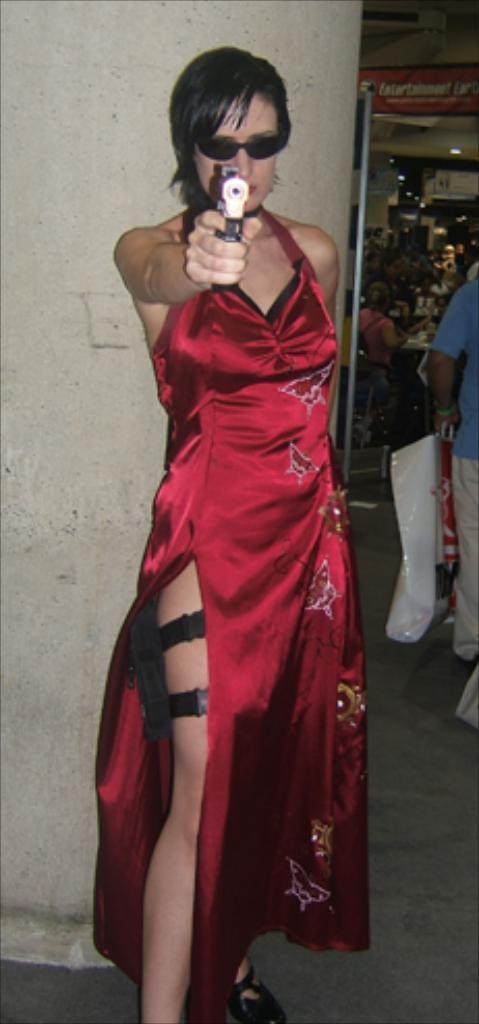How would you summarize this image in a sentence or two? In the foreground, I can see a woman is holding a gun in hand. In the background, I can see a pillar, group of people on the floor, some objects and lights on a rooftop. This image is taken, maybe in a shop. 